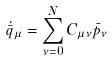Convert formula to latex. <formula><loc_0><loc_0><loc_500><loc_500>\dot { \bar { q } } _ { \mu } = \sum _ { \nu = 0 } ^ { N } C _ { \mu \nu } \bar { p } _ { \nu }</formula> 